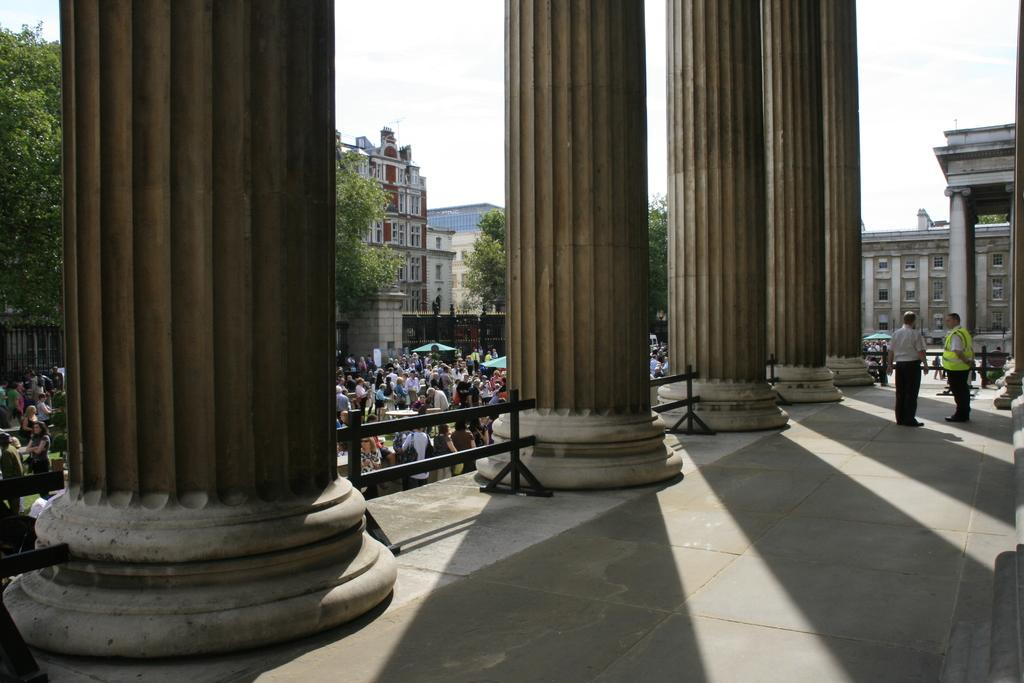What type of architectural feature is present in the image? There are pillars with railings in the image. How many people can be seen in the image? There are many people in the image. What can be seen in the background of the image? There are buildings with windows and trees in the background of the image. What is visible in the sky in the image? The sky is visible in the background of the image. What type of ear is visible on the person in the image? There is no specific ear visible in the image, as it is focused on the architectural features and the presence of people. What is the person in the image having for lunch? There is no indication of lunch or any food in the image. 